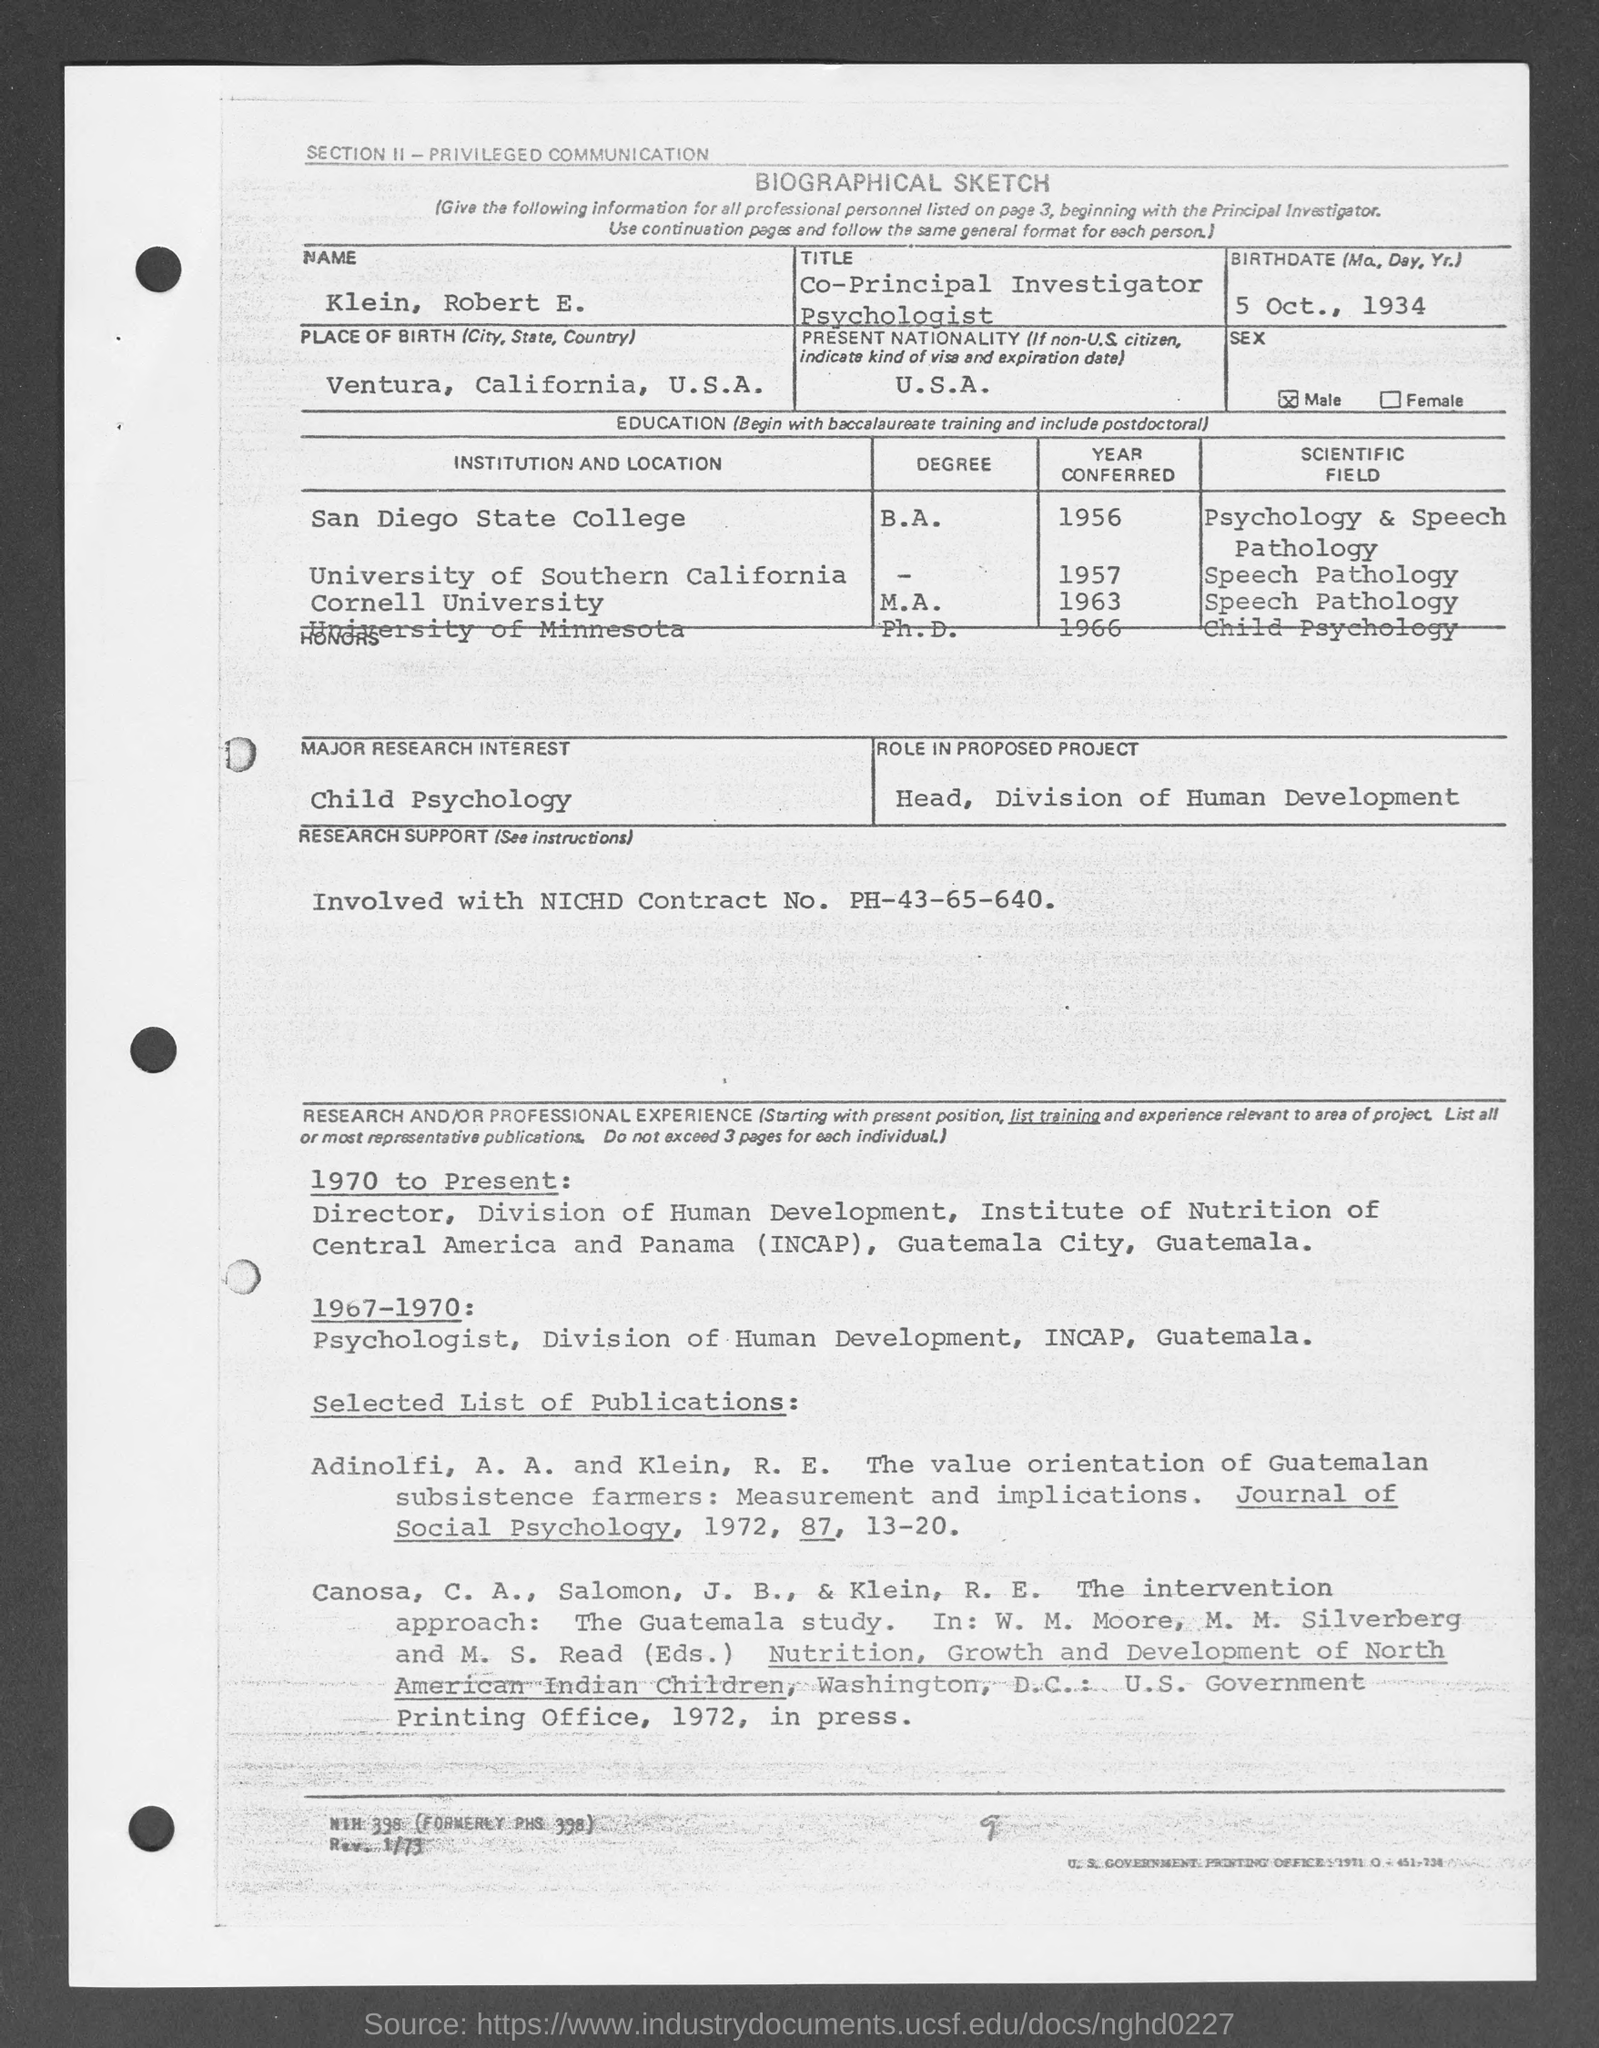Point out several critical features in this image. I am the Head of the Division of Human Development and my role in the proposed project is to lead and oversee its progression. He was a student at Cornell University in 1963. The current nationality of the person mentioned is the United States of America. On October 5th, 1934, the person's birthdate was. Place of birth: Ventura, California, USA. 